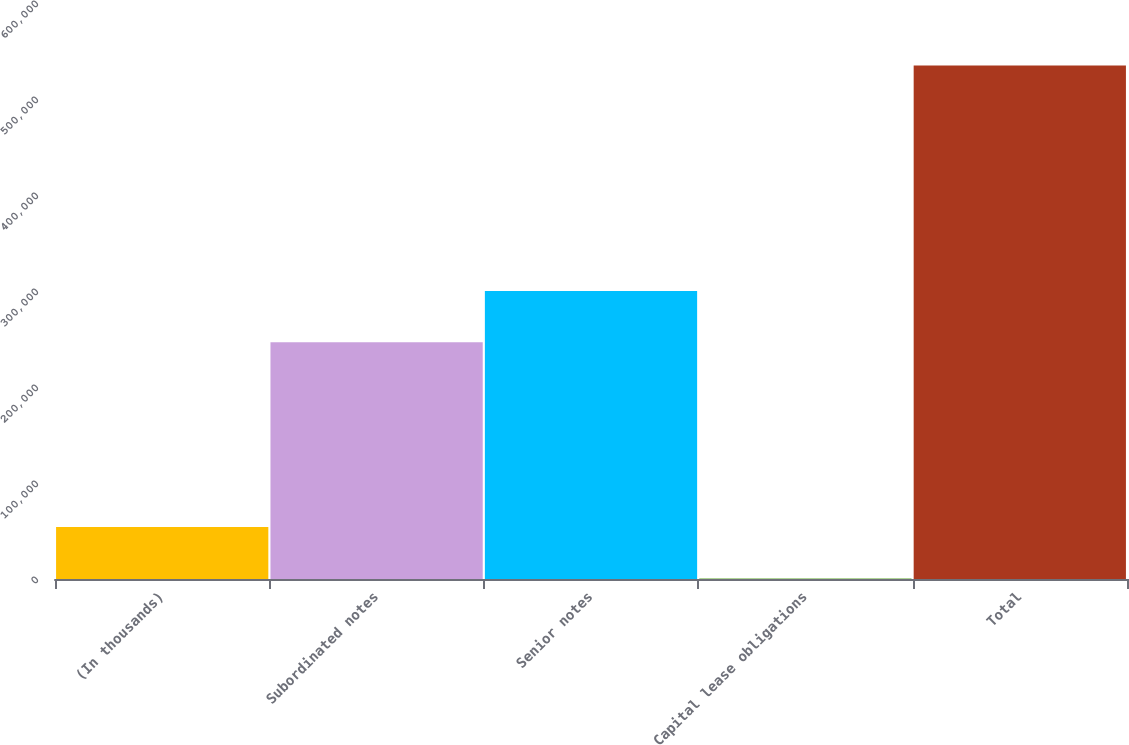<chart> <loc_0><loc_0><loc_500><loc_500><bar_chart><fcel>(In thousands)<fcel>Subordinated notes<fcel>Senior notes<fcel>Capital lease obligations<fcel>Total<nl><fcel>54151<fcel>246550<fcel>299961<fcel>740<fcel>534850<nl></chart> 